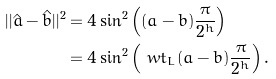Convert formula to latex. <formula><loc_0><loc_0><loc_500><loc_500>| | \hat { a } - \hat { b } | | ^ { 2 } & = 4 \sin ^ { 2 } \left ( ( a - b ) \frac { \pi } { 2 ^ { h } } \right ) \\ & = 4 \sin ^ { 2 } \left ( \ w t _ { L } ( a - b ) \frac { \pi } { 2 ^ { h } } \right ) .</formula> 